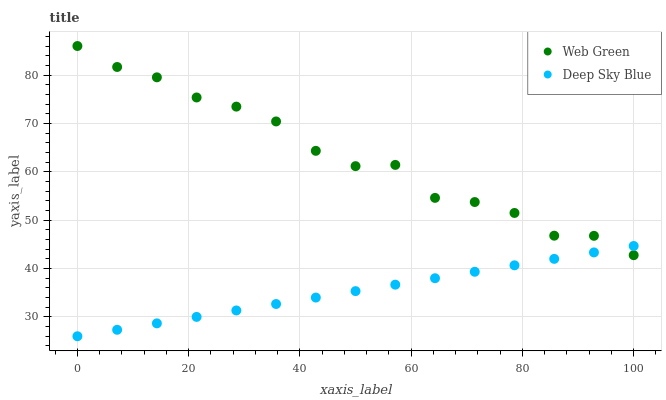Does Deep Sky Blue have the minimum area under the curve?
Answer yes or no. Yes. Does Web Green have the maximum area under the curve?
Answer yes or no. Yes. Does Web Green have the minimum area under the curve?
Answer yes or no. No. Is Deep Sky Blue the smoothest?
Answer yes or no. Yes. Is Web Green the roughest?
Answer yes or no. Yes. Is Web Green the smoothest?
Answer yes or no. No. Does Deep Sky Blue have the lowest value?
Answer yes or no. Yes. Does Web Green have the lowest value?
Answer yes or no. No. Does Web Green have the highest value?
Answer yes or no. Yes. Does Web Green intersect Deep Sky Blue?
Answer yes or no. Yes. Is Web Green less than Deep Sky Blue?
Answer yes or no. No. Is Web Green greater than Deep Sky Blue?
Answer yes or no. No. 